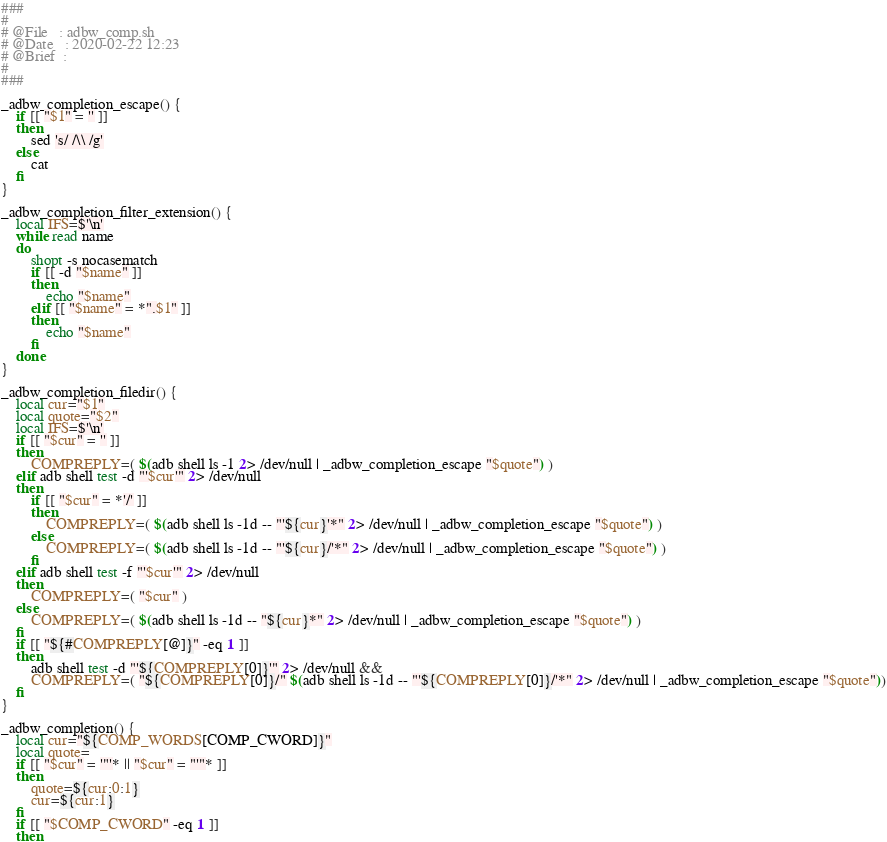<code> <loc_0><loc_0><loc_500><loc_500><_Bash_>
###
# 
# @File   : adbw_comp.sh   
# @Date   : 2020-02-22 12:23   
# @Brief  :  
# 
###

_adbw_completion_escape() {
    if [[ "$1" = '' ]]
    then
        sed 's/ /\\ /g'
    else
        cat
    fi
}

_adbw_completion_filter_extension() {
    local IFS=$'\n'
    while read name
    do
        shopt -s nocasematch
        if [[ -d "$name" ]]
        then
            echo "$name"
        elif [[ "$name" = *".$1" ]]
        then
            echo "$name"
        fi
    done
}

_adbw_completion_filedir() {
    local cur="$1"
    local quote="$2"
    local IFS=$'\n'
    if [[ "$cur" = '' ]]
    then
        COMPREPLY=( $(adb shell ls -1 2> /dev/null | _adbw_completion_escape "$quote") )
    elif adb shell test -d "'$cur'" 2> /dev/null
    then
        if [[ "$cur" = *'/' ]]
        then
            COMPREPLY=( $(adb shell ls -1d -- "'${cur}'*" 2> /dev/null | _adbw_completion_escape "$quote") )
        else
            COMPREPLY=( $(adb shell ls -1d -- "'${cur}/'*" 2> /dev/null | _adbw_completion_escape "$quote") )
        fi
    elif adb shell test -f "'$cur'" 2> /dev/null
    then
        COMPREPLY=( "$cur" )
    else
        COMPREPLY=( $(adb shell ls -1d -- "${cur}*" 2> /dev/null | _adbw_completion_escape "$quote") )
    fi
    if [[ "${#COMPREPLY[@]}" -eq 1 ]]
    then
        adb shell test -d "'${COMPREPLY[0]}'" 2> /dev/null &&
        COMPREPLY=( "${COMPREPLY[0]}/" $(adb shell ls -1d -- "'${COMPREPLY[0]}/'*" 2> /dev/null | _adbw_completion_escape "$quote"))
    fi
}

_adbw_completion() {
    local cur="${COMP_WORDS[COMP_CWORD]}"
    local quote=
    if [[ "$cur" = '"'* || "$cur" = "'"* ]]
    then
        quote=${cur:0:1}
        cur=${cur:1}
    fi
    if [[ "$COMP_CWORD" -eq 1 ]]
    then</code> 